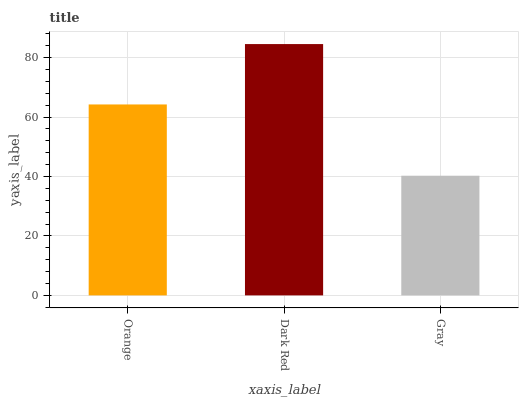Is Dark Red the minimum?
Answer yes or no. No. Is Gray the maximum?
Answer yes or no. No. Is Dark Red greater than Gray?
Answer yes or no. Yes. Is Gray less than Dark Red?
Answer yes or no. Yes. Is Gray greater than Dark Red?
Answer yes or no. No. Is Dark Red less than Gray?
Answer yes or no. No. Is Orange the high median?
Answer yes or no. Yes. Is Orange the low median?
Answer yes or no. Yes. Is Dark Red the high median?
Answer yes or no. No. Is Gray the low median?
Answer yes or no. No. 